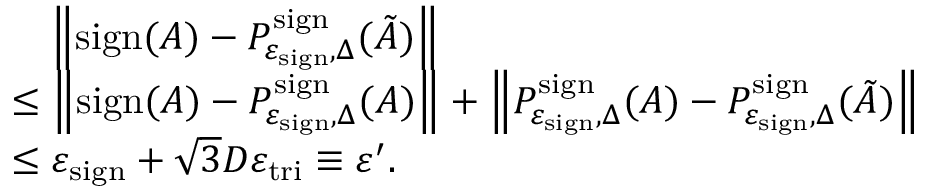Convert formula to latex. <formula><loc_0><loc_0><loc_500><loc_500>\begin{array} { r l } & { \quad \left \| s i g n ( A ) - P _ { \varepsilon _ { s i g n } , \Delta } ^ { s i g n } ( \tilde { A } ) \right \| } \\ & { \leq \left \| s i g n ( A ) - P _ { \varepsilon _ { s i g n } , \Delta } ^ { s i g n } ( A ) \right \| + \left \| P _ { \varepsilon _ { s i g n } , \Delta } ^ { s i g n } ( A ) - P _ { \varepsilon _ { s i g n } , \Delta } ^ { s i g n } ( \tilde { A } ) \right \| } \\ & { \leq \varepsilon _ { s i g n } + \sqrt { 3 } D \varepsilon _ { t r i } \equiv \varepsilon ^ { \prime } . } \end{array}</formula> 